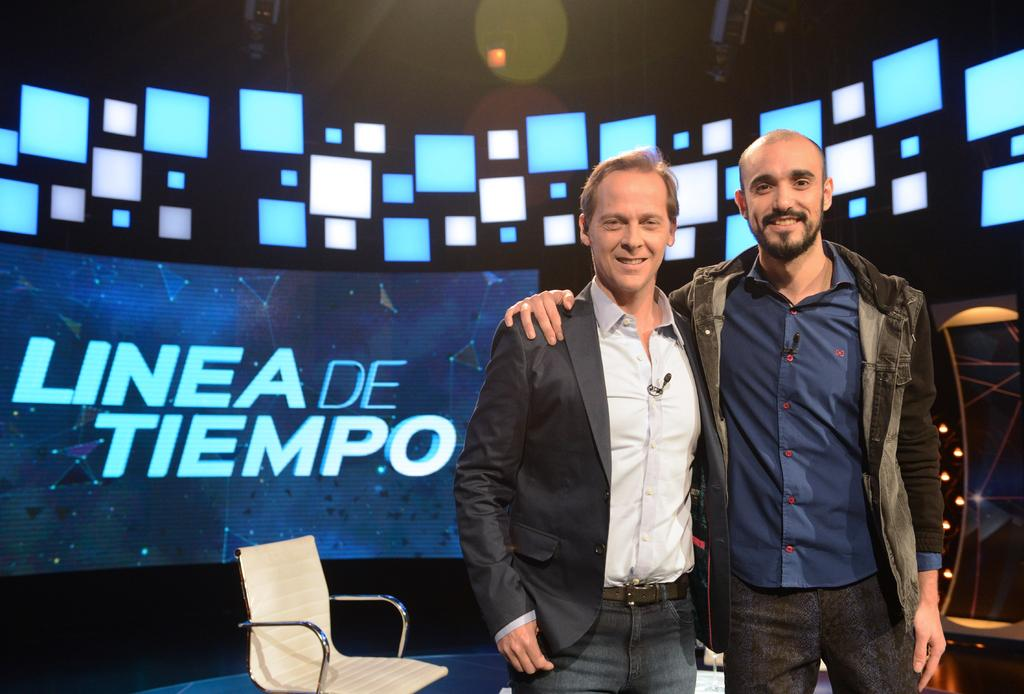How many people are in the image? There are two persons in the image. What are the persons wearing? Both persons are wearing jackets. What are the persons doing in the image? The persons are standing and smiling. What can be seen in the background of the image? There is a chair, a screen, and lights visible in the background of the image. What type of bird can be seen flying in the image? There is no bird visible in the image. Can you tell me how many volleyballs are present in the image? There are no volleyballs present in the image. 